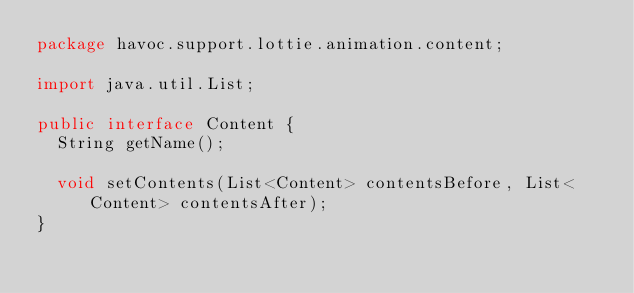Convert code to text. <code><loc_0><loc_0><loc_500><loc_500><_Java_>package havoc.support.lottie.animation.content;

import java.util.List;

public interface Content {
  String getName();

  void setContents(List<Content> contentsBefore, List<Content> contentsAfter);
}
</code> 